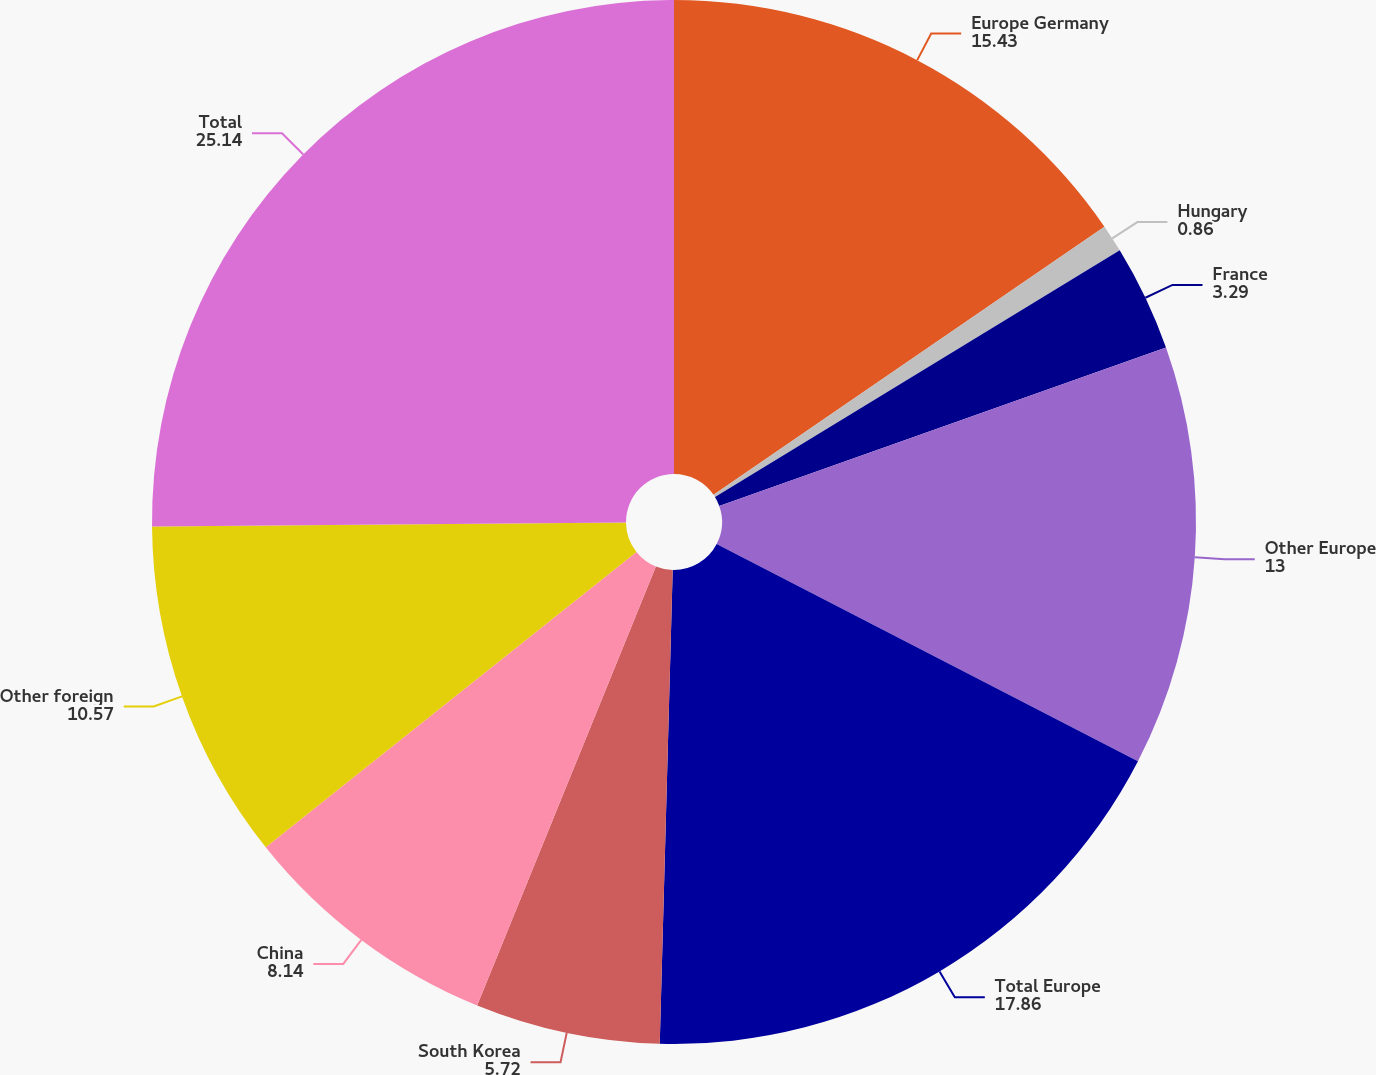<chart> <loc_0><loc_0><loc_500><loc_500><pie_chart><fcel>Europe Germany<fcel>Hungary<fcel>France<fcel>Other Europe<fcel>Total Europe<fcel>South Korea<fcel>China<fcel>Other foreign<fcel>Total<nl><fcel>15.43%<fcel>0.86%<fcel>3.29%<fcel>13.0%<fcel>17.86%<fcel>5.72%<fcel>8.14%<fcel>10.57%<fcel>25.14%<nl></chart> 